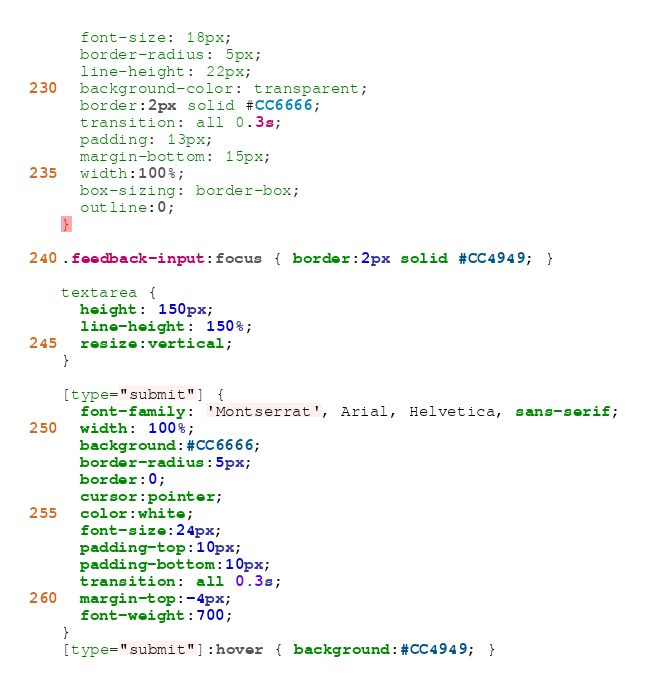<code> <loc_0><loc_0><loc_500><loc_500><_CSS_>  font-size: 18px;
  border-radius: 5px;
  line-height: 22px;
  background-color: transparent;
  border:2px solid #CC6666;
  transition: all 0.3s;
  padding: 13px;
  margin-bottom: 15px;
  width:100%;
  box-sizing: border-box;
  outline:0;
}

.feedback-input:focus { border:2px solid #CC4949; }

textarea {
  height: 150px;
  line-height: 150%;
  resize:vertical;
}

[type="submit"] {
  font-family: 'Montserrat', Arial, Helvetica, sans-serif;
  width: 100%;
  background:#CC6666;
  border-radius:5px;
  border:0;
  cursor:pointer;
  color:white;
  font-size:24px;
  padding-top:10px;
  padding-bottom:10px;
  transition: all 0.3s;
  margin-top:-4px;
  font-weight:700;
}
[type="submit"]:hover { background:#CC4949; }
</code> 